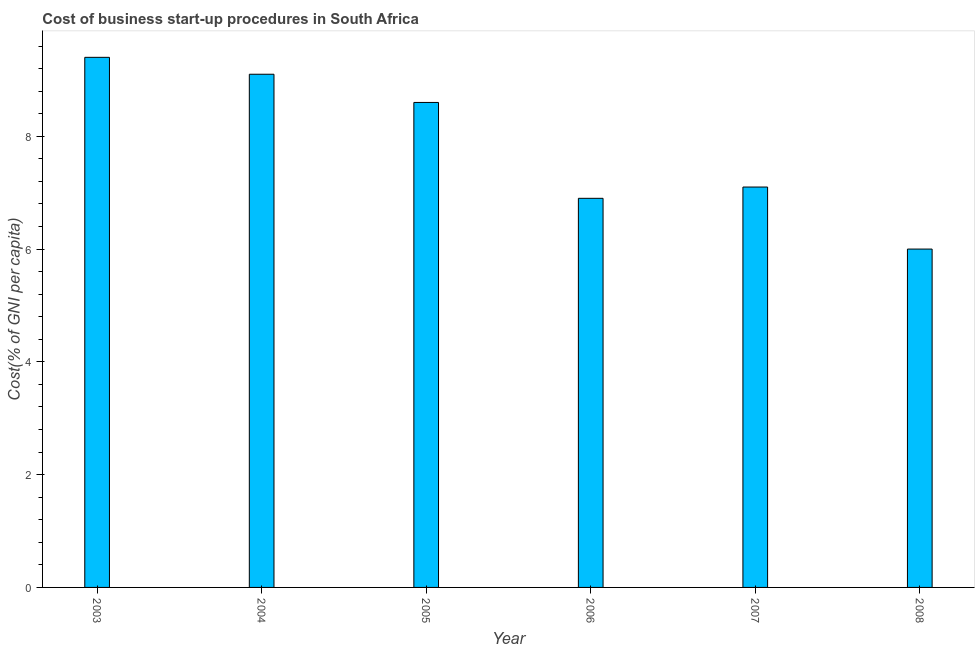What is the title of the graph?
Give a very brief answer. Cost of business start-up procedures in South Africa. What is the label or title of the Y-axis?
Keep it short and to the point. Cost(% of GNI per capita). What is the cost of business startup procedures in 2006?
Offer a terse response. 6.9. In which year was the cost of business startup procedures maximum?
Make the answer very short. 2003. What is the sum of the cost of business startup procedures?
Give a very brief answer. 47.1. What is the difference between the cost of business startup procedures in 2004 and 2008?
Provide a succinct answer. 3.1. What is the average cost of business startup procedures per year?
Make the answer very short. 7.85. What is the median cost of business startup procedures?
Provide a short and direct response. 7.85. Do a majority of the years between 2008 and 2007 (inclusive) have cost of business startup procedures greater than 1.6 %?
Offer a terse response. No. What is the ratio of the cost of business startup procedures in 2005 to that in 2008?
Give a very brief answer. 1.43. Is the sum of the cost of business startup procedures in 2003 and 2008 greater than the maximum cost of business startup procedures across all years?
Keep it short and to the point. Yes. What is the difference between the highest and the lowest cost of business startup procedures?
Provide a succinct answer. 3.4. How many bars are there?
Keep it short and to the point. 6. Are the values on the major ticks of Y-axis written in scientific E-notation?
Offer a very short reply. No. What is the Cost(% of GNI per capita) of 2003?
Your answer should be compact. 9.4. What is the Cost(% of GNI per capita) in 2004?
Provide a succinct answer. 9.1. What is the Cost(% of GNI per capita) of 2005?
Give a very brief answer. 8.6. What is the Cost(% of GNI per capita) of 2006?
Ensure brevity in your answer.  6.9. What is the Cost(% of GNI per capita) in 2008?
Give a very brief answer. 6. What is the difference between the Cost(% of GNI per capita) in 2003 and 2005?
Your answer should be compact. 0.8. What is the difference between the Cost(% of GNI per capita) in 2003 and 2007?
Your answer should be very brief. 2.3. What is the difference between the Cost(% of GNI per capita) in 2004 and 2005?
Give a very brief answer. 0.5. What is the difference between the Cost(% of GNI per capita) in 2004 and 2007?
Your response must be concise. 2. What is the difference between the Cost(% of GNI per capita) in 2005 and 2007?
Keep it short and to the point. 1.5. What is the difference between the Cost(% of GNI per capita) in 2005 and 2008?
Your answer should be very brief. 2.6. What is the difference between the Cost(% of GNI per capita) in 2006 and 2007?
Provide a short and direct response. -0.2. What is the difference between the Cost(% of GNI per capita) in 2006 and 2008?
Offer a terse response. 0.9. What is the ratio of the Cost(% of GNI per capita) in 2003 to that in 2004?
Your answer should be very brief. 1.03. What is the ratio of the Cost(% of GNI per capita) in 2003 to that in 2005?
Make the answer very short. 1.09. What is the ratio of the Cost(% of GNI per capita) in 2003 to that in 2006?
Keep it short and to the point. 1.36. What is the ratio of the Cost(% of GNI per capita) in 2003 to that in 2007?
Your answer should be compact. 1.32. What is the ratio of the Cost(% of GNI per capita) in 2003 to that in 2008?
Make the answer very short. 1.57. What is the ratio of the Cost(% of GNI per capita) in 2004 to that in 2005?
Ensure brevity in your answer.  1.06. What is the ratio of the Cost(% of GNI per capita) in 2004 to that in 2006?
Your response must be concise. 1.32. What is the ratio of the Cost(% of GNI per capita) in 2004 to that in 2007?
Your response must be concise. 1.28. What is the ratio of the Cost(% of GNI per capita) in 2004 to that in 2008?
Your answer should be very brief. 1.52. What is the ratio of the Cost(% of GNI per capita) in 2005 to that in 2006?
Give a very brief answer. 1.25. What is the ratio of the Cost(% of GNI per capita) in 2005 to that in 2007?
Make the answer very short. 1.21. What is the ratio of the Cost(% of GNI per capita) in 2005 to that in 2008?
Ensure brevity in your answer.  1.43. What is the ratio of the Cost(% of GNI per capita) in 2006 to that in 2007?
Keep it short and to the point. 0.97. What is the ratio of the Cost(% of GNI per capita) in 2006 to that in 2008?
Keep it short and to the point. 1.15. What is the ratio of the Cost(% of GNI per capita) in 2007 to that in 2008?
Make the answer very short. 1.18. 